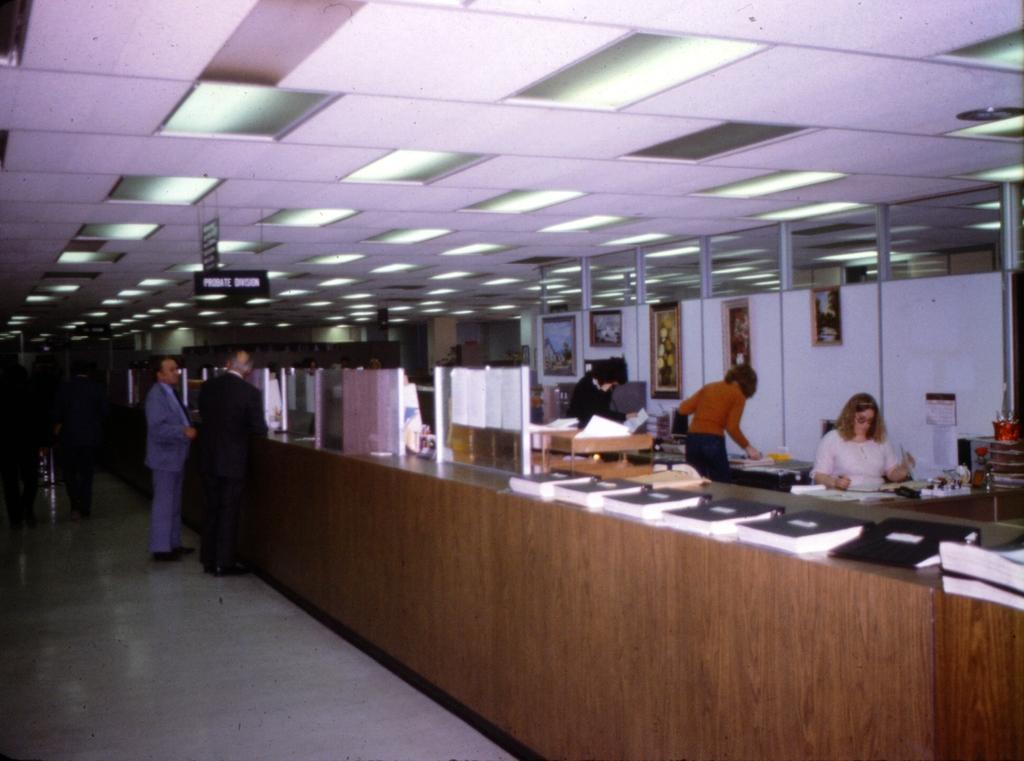Could you give a brief overview of what you see in this image? In the image on the right side there is a table. On the table there are files, papers, small glass walls and some other objects. And in the image there are few people. In the background there are walls with frames. At the top of the image there is a ceiling with lights and name boards are hanging. 